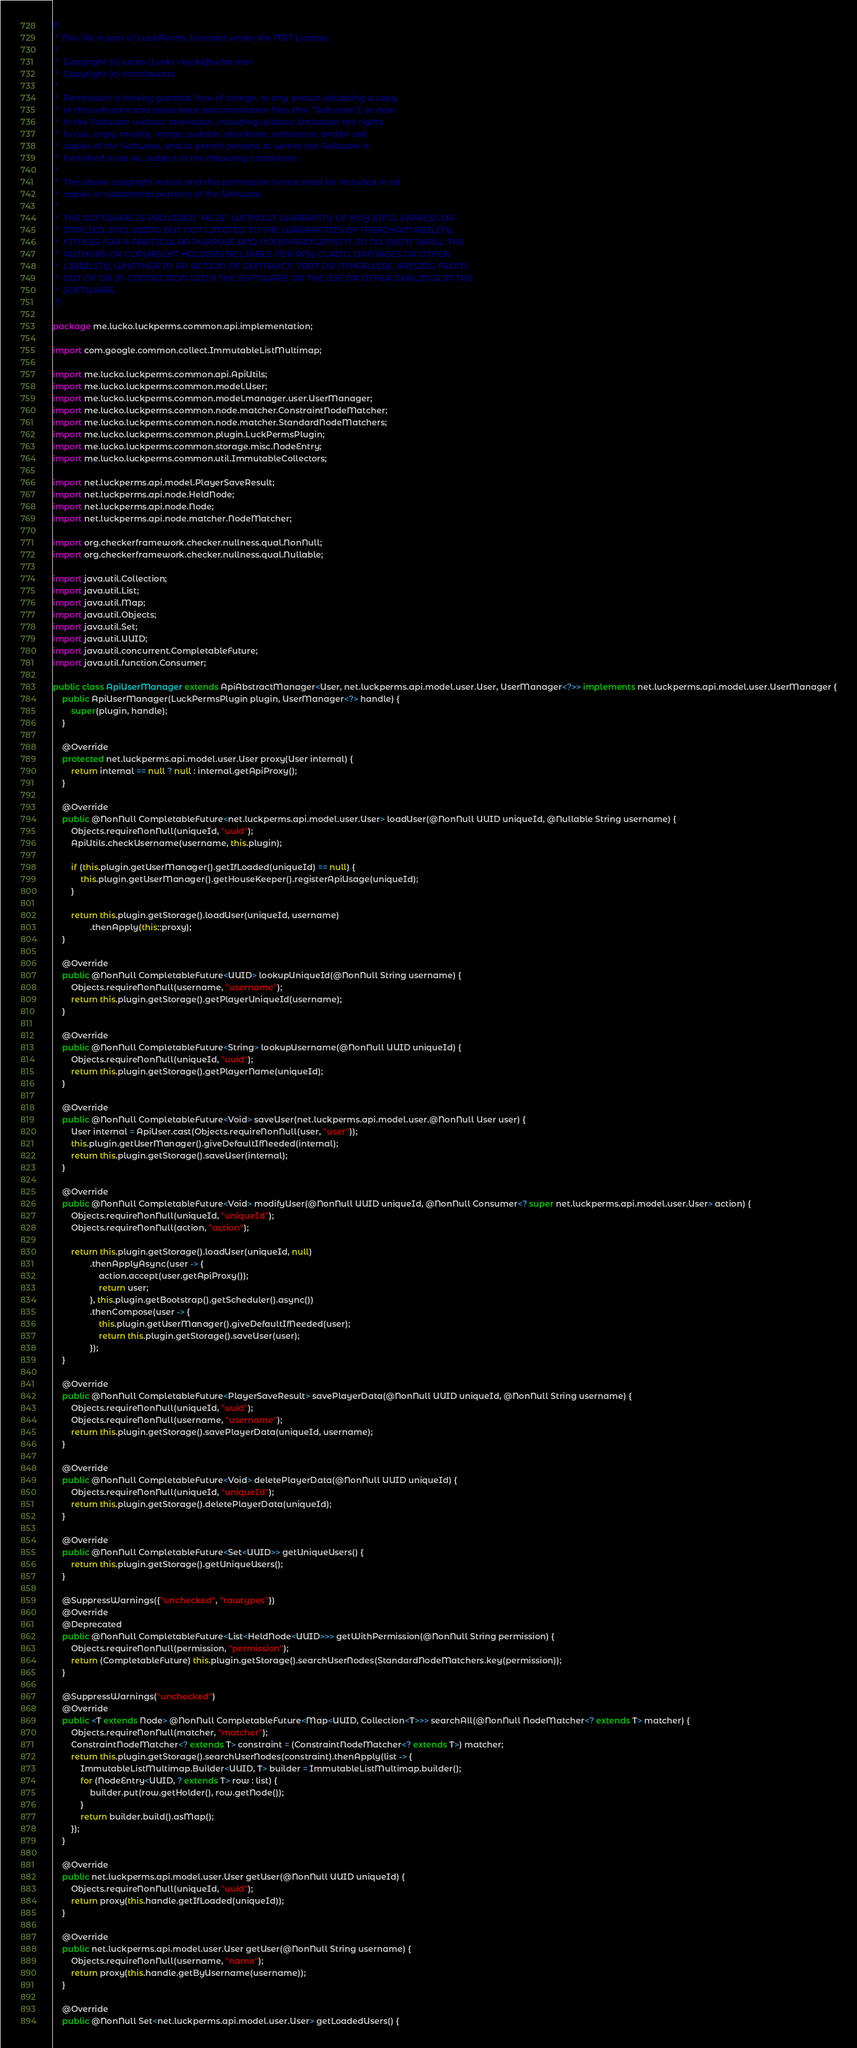<code> <loc_0><loc_0><loc_500><loc_500><_Java_>/*
 * This file is part of LuckPerms, licensed under the MIT License.
 *
 *  Copyright (c) lucko (Luck) <luck@lucko.me>
 *  Copyright (c) contributors
 *
 *  Permission is hereby granted, free of charge, to any person obtaining a copy
 *  of this software and associated documentation files (the "Software"), to deal
 *  in the Software without restriction, including without limitation the rights
 *  to use, copy, modify, merge, publish, distribute, sublicense, and/or sell
 *  copies of the Software, and to permit persons to whom the Software is
 *  furnished to do so, subject to the following conditions:
 *
 *  The above copyright notice and this permission notice shall be included in all
 *  copies or substantial portions of the Software.
 *
 *  THE SOFTWARE IS PROVIDED "AS IS", WITHOUT WARRANTY OF ANY KIND, EXPRESS OR
 *  IMPLIED, INCLUDING BUT NOT LIMITED TO THE WARRANTIES OF MERCHANTABILITY,
 *  FITNESS FOR A PARTICULAR PURPOSE AND NONINFRINGEMENT. IN NO EVENT SHALL THE
 *  AUTHORS OR COPYRIGHT HOLDERS BE LIABLE FOR ANY CLAIM, DAMAGES OR OTHER
 *  LIABILITY, WHETHER IN AN ACTION OF CONTRACT, TORT OR OTHERWISE, ARISING FROM,
 *  OUT OF OR IN CONNECTION WITH THE SOFTWARE OR THE USE OR OTHER DEALINGS IN THE
 *  SOFTWARE.
 */

package me.lucko.luckperms.common.api.implementation;

import com.google.common.collect.ImmutableListMultimap;

import me.lucko.luckperms.common.api.ApiUtils;
import me.lucko.luckperms.common.model.User;
import me.lucko.luckperms.common.model.manager.user.UserManager;
import me.lucko.luckperms.common.node.matcher.ConstraintNodeMatcher;
import me.lucko.luckperms.common.node.matcher.StandardNodeMatchers;
import me.lucko.luckperms.common.plugin.LuckPermsPlugin;
import me.lucko.luckperms.common.storage.misc.NodeEntry;
import me.lucko.luckperms.common.util.ImmutableCollectors;

import net.luckperms.api.model.PlayerSaveResult;
import net.luckperms.api.node.HeldNode;
import net.luckperms.api.node.Node;
import net.luckperms.api.node.matcher.NodeMatcher;

import org.checkerframework.checker.nullness.qual.NonNull;
import org.checkerframework.checker.nullness.qual.Nullable;

import java.util.Collection;
import java.util.List;
import java.util.Map;
import java.util.Objects;
import java.util.Set;
import java.util.UUID;
import java.util.concurrent.CompletableFuture;
import java.util.function.Consumer;

public class ApiUserManager extends ApiAbstractManager<User, net.luckperms.api.model.user.User, UserManager<?>> implements net.luckperms.api.model.user.UserManager {
    public ApiUserManager(LuckPermsPlugin plugin, UserManager<?> handle) {
        super(plugin, handle);
    }

    @Override
    protected net.luckperms.api.model.user.User proxy(User internal) {
        return internal == null ? null : internal.getApiProxy();
    }

    @Override
    public @NonNull CompletableFuture<net.luckperms.api.model.user.User> loadUser(@NonNull UUID uniqueId, @Nullable String username) {
        Objects.requireNonNull(uniqueId, "uuid");
        ApiUtils.checkUsername(username, this.plugin);

        if (this.plugin.getUserManager().getIfLoaded(uniqueId) == null) {
            this.plugin.getUserManager().getHouseKeeper().registerApiUsage(uniqueId);
        }

        return this.plugin.getStorage().loadUser(uniqueId, username)
                .thenApply(this::proxy);
    }

    @Override
    public @NonNull CompletableFuture<UUID> lookupUniqueId(@NonNull String username) {
        Objects.requireNonNull(username, "username");
        return this.plugin.getStorage().getPlayerUniqueId(username);
    }

    @Override
    public @NonNull CompletableFuture<String> lookupUsername(@NonNull UUID uniqueId) {
        Objects.requireNonNull(uniqueId, "uuid");
        return this.plugin.getStorage().getPlayerName(uniqueId);
    }

    @Override
    public @NonNull CompletableFuture<Void> saveUser(net.luckperms.api.model.user.@NonNull User user) {
        User internal = ApiUser.cast(Objects.requireNonNull(user, "user"));
        this.plugin.getUserManager().giveDefaultIfNeeded(internal);
        return this.plugin.getStorage().saveUser(internal);
    }

    @Override
    public @NonNull CompletableFuture<Void> modifyUser(@NonNull UUID uniqueId, @NonNull Consumer<? super net.luckperms.api.model.user.User> action) {
        Objects.requireNonNull(uniqueId, "uniqueId");
        Objects.requireNonNull(action, "action");

        return this.plugin.getStorage().loadUser(uniqueId, null)
                .thenApplyAsync(user -> {
                    action.accept(user.getApiProxy());
                    return user;
                }, this.plugin.getBootstrap().getScheduler().async())
                .thenCompose(user -> {
                    this.plugin.getUserManager().giveDefaultIfNeeded(user);
                    return this.plugin.getStorage().saveUser(user);
                });
    }

    @Override
    public @NonNull CompletableFuture<PlayerSaveResult> savePlayerData(@NonNull UUID uniqueId, @NonNull String username) {
        Objects.requireNonNull(uniqueId, "uuid");
        Objects.requireNonNull(username, "username");
        return this.plugin.getStorage().savePlayerData(uniqueId, username);
    }

    @Override
    public @NonNull CompletableFuture<Void> deletePlayerData(@NonNull UUID uniqueId) {
        Objects.requireNonNull(uniqueId, "uniqueId");
        return this.plugin.getStorage().deletePlayerData(uniqueId);
    }

    @Override
    public @NonNull CompletableFuture<Set<UUID>> getUniqueUsers() {
        return this.plugin.getStorage().getUniqueUsers();
    }

    @SuppressWarnings({"unchecked", "rawtypes"})
    @Override
    @Deprecated
    public @NonNull CompletableFuture<List<HeldNode<UUID>>> getWithPermission(@NonNull String permission) {
        Objects.requireNonNull(permission, "permission");
        return (CompletableFuture) this.plugin.getStorage().searchUserNodes(StandardNodeMatchers.key(permission));
    }

    @SuppressWarnings("unchecked")
    @Override
    public <T extends Node> @NonNull CompletableFuture<Map<UUID, Collection<T>>> searchAll(@NonNull NodeMatcher<? extends T> matcher) {
        Objects.requireNonNull(matcher, "matcher");
        ConstraintNodeMatcher<? extends T> constraint = (ConstraintNodeMatcher<? extends T>) matcher;
        return this.plugin.getStorage().searchUserNodes(constraint).thenApply(list -> {
            ImmutableListMultimap.Builder<UUID, T> builder = ImmutableListMultimap.builder();
            for (NodeEntry<UUID, ? extends T> row : list) {
                builder.put(row.getHolder(), row.getNode());
            }
            return builder.build().asMap();
        });
    }

    @Override
    public net.luckperms.api.model.user.User getUser(@NonNull UUID uniqueId) {
        Objects.requireNonNull(uniqueId, "uuid");
        return proxy(this.handle.getIfLoaded(uniqueId));
    }

    @Override
    public net.luckperms.api.model.user.User getUser(@NonNull String username) {
        Objects.requireNonNull(username, "name");
        return proxy(this.handle.getByUsername(username));
    }

    @Override
    public @NonNull Set<net.luckperms.api.model.user.User> getLoadedUsers() {</code> 